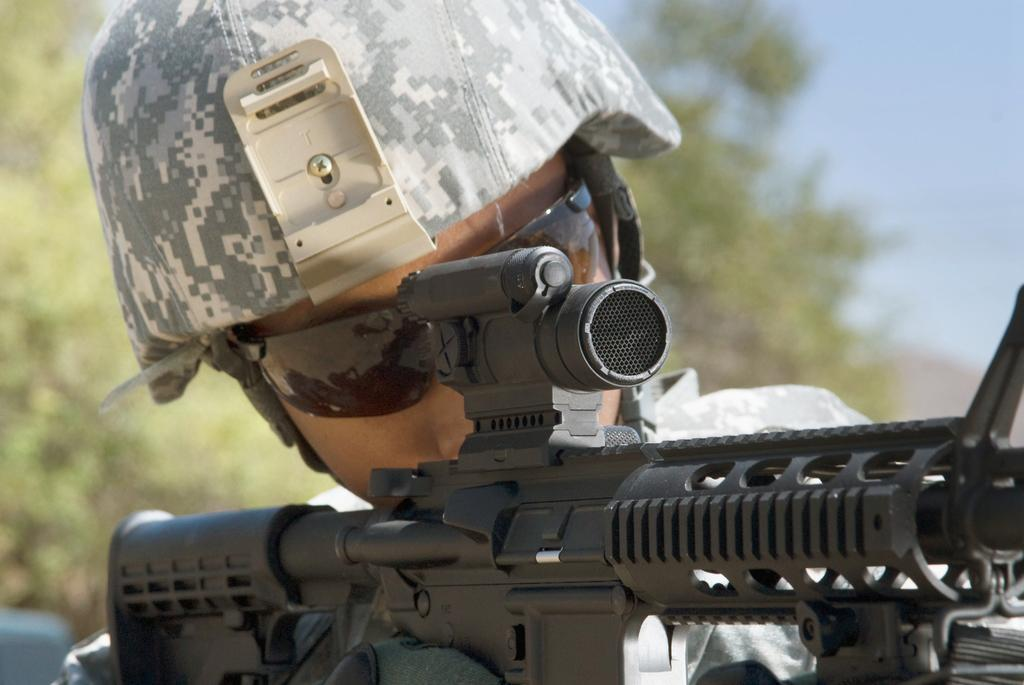What is the main subject of the image? The main subject of the image is a man. What is the man wearing in the image? The man is wearing a uniform in the image. What is the man holding in his hand in the image? The man is holding a rifle in his hand in the image. What can be seen in the background of the image? There are trees and the sky visible in the background of the image. How many captions are present in the image? There are no captions present in the image. What type of note can be seen on the man's uniform? There is no note visible on the man's uniform in the image. 